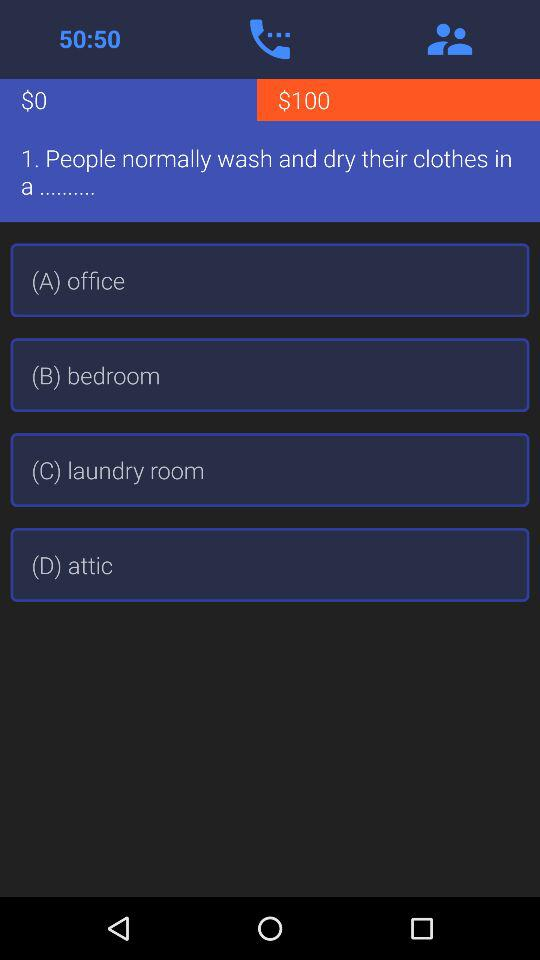What is the question? The question is "People normally wash and dry their clothes in a..........". 